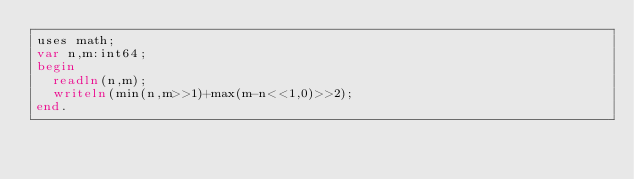<code> <loc_0><loc_0><loc_500><loc_500><_Pascal_>uses math;
var n,m:int64;
begin
  readln(n,m);
  writeln(min(n,m>>1)+max(m-n<<1,0)>>2);
end.</code> 